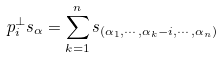<formula> <loc_0><loc_0><loc_500><loc_500>p ^ { \perp } _ { i } s _ { \alpha } = \sum _ { k = 1 } ^ { n } s _ { ( \alpha _ { 1 } , \cdots , \alpha _ { k } - i , \cdots , \alpha _ { n } ) }</formula> 